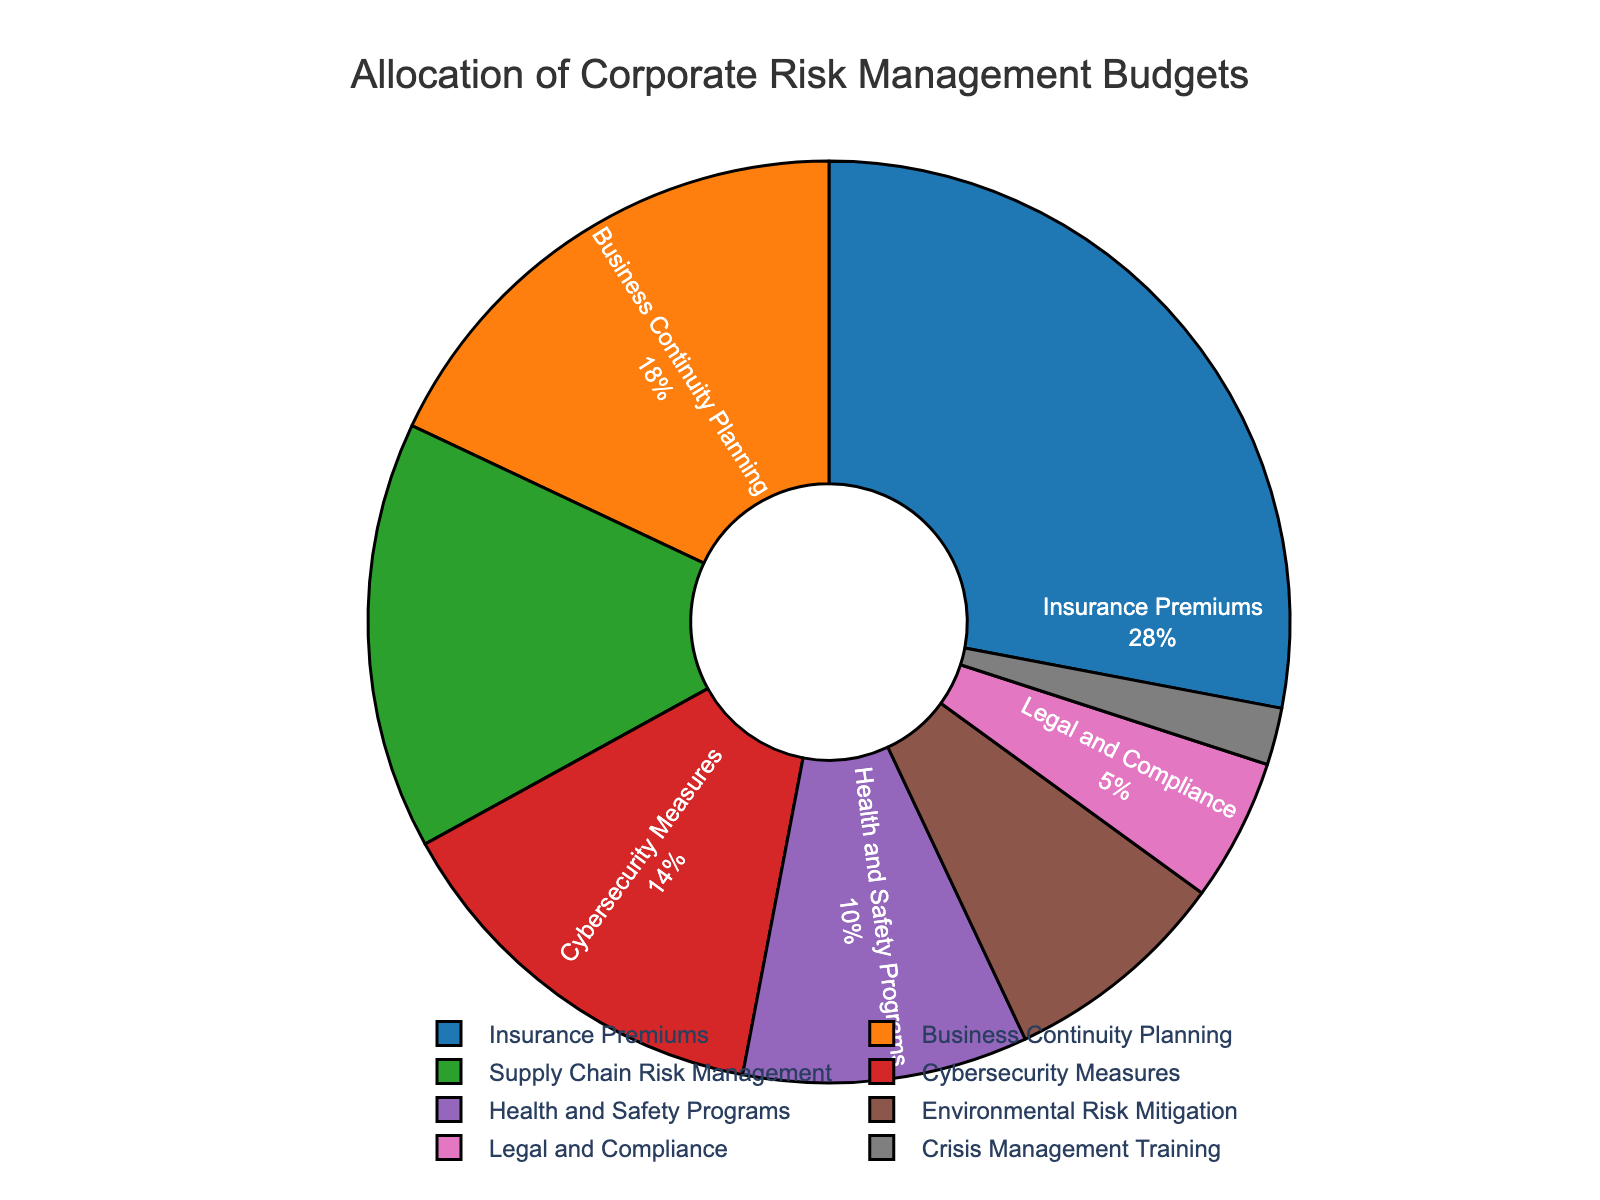Which strategy has the highest budget allocation? The strategy with the highest budget allocation is the one with the largest percentage shown in the pie chart.
Answer: Insurance Premiums Which strategy has the smallest budget allocation? The strategy with the smallest budget allocation is the one with the smallest percentage shown in the pie chart.
Answer: Crisis Management Training What is the combined budget allocation for Cybersecurity Measures and Health and Safety Programs? Add the percentage values for Cybersecurity Measures and Health and Safety Programs: 14% + 10% = 24%.
Answer: 24% Is the budget allocation for Supply Chain Risk Management greater than for Environmental Risk Mitigation? Compare the percentages of Supply Chain Risk Management (15%) and Environmental Risk Mitigation (8%). Since 15% > 8%, the answer is yes.
Answer: Yes What fraction of the total budget is allocated to Business Continuity Planning and Legal and Compliance combined? Add the percentages for Business Continuity Planning and Legal and Compliance: 18% + 5% = 23%.
Answer: 23% How much more budget is allocated to Insurance Premiums compared to Crisis Management Training? Subtract the percentage of Crisis Management Training from Insurance Premiums: 28% - 2% = 26%.
Answer: 26% If the total budget is $1 million, how much is allocated to Environmental Risk Mitigation? Calculate 8% of $1 million: 0.08 * $1,000,000 = $80,000.
Answer: $80,000 Which two strategies combined have a larger budget allocation than Cybersecurity Measures but less than Supply Chain Risk Management and Health and Safety Programs combined? To be less than Supply Chain Risk Management (15%) and Health and Safety Programs (10%), but more than Cybersecurity Measures (14%), select Business Continuity Planning (18%) which is larger than 14% but less than 25% combined.
Answer: Business Continuity Planning 